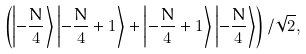<formula> <loc_0><loc_0><loc_500><loc_500>\left ( \left | - \frac { N } { 4 } \right \rangle \left | - \frac { N } { 4 } + 1 \right \rangle + \left | - \frac { N } { 4 } + 1 \right \rangle \left | - \frac { N } { 4 } \right \rangle \right ) / \sqrt { 2 } ,</formula> 